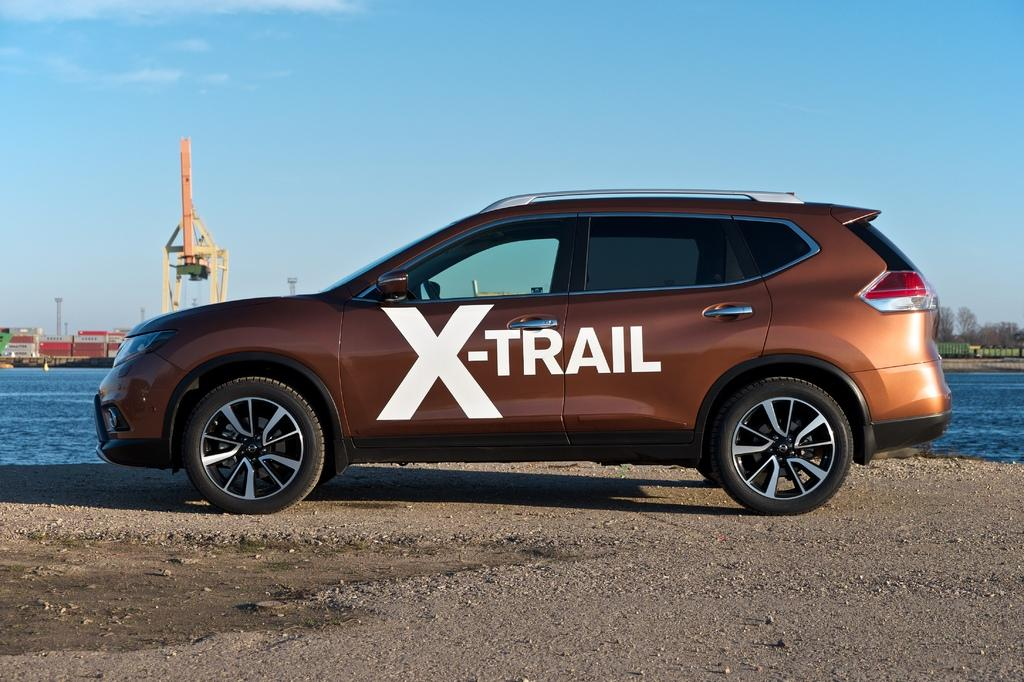What is the main subject of the image? The main subject of the image is a car. What can be seen in the foreground of the image? There is water visible in the image. What type of structures can be seen in the background of the image? There are sheds, trees, and towers in the background of the image. What is visible in the sky in the image? The sky is visible in the background of the image. What type of machinery is visible in the image? There is a crane visible in the image. What type of grass is growing in the harbor in the image? There is no harbor present in the image, and therefore no grass growing in it. 